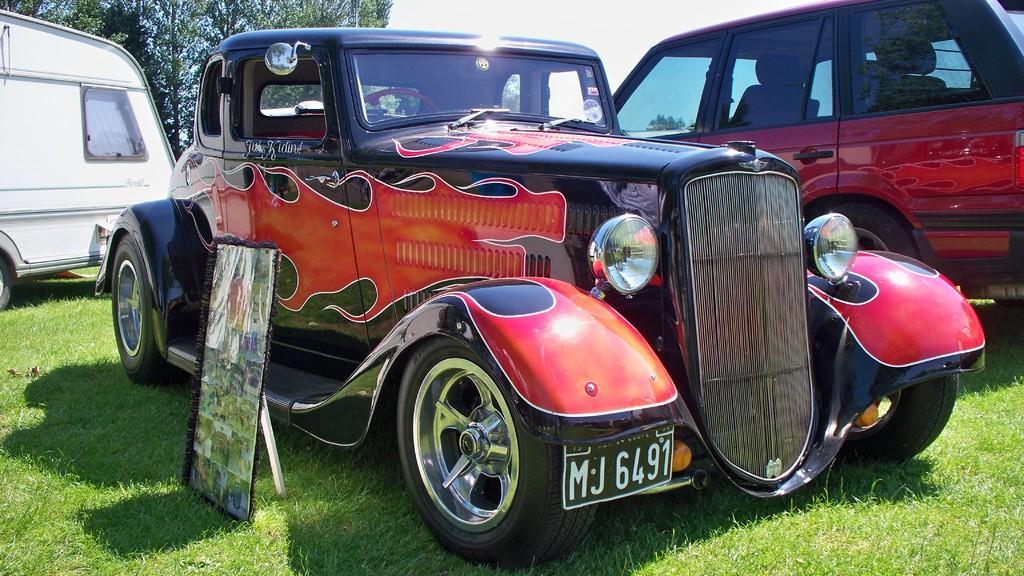Could you give a brief overview of what you see in this image? In this image we can see vehicles on the grass. In the background we can see tree and sky. 